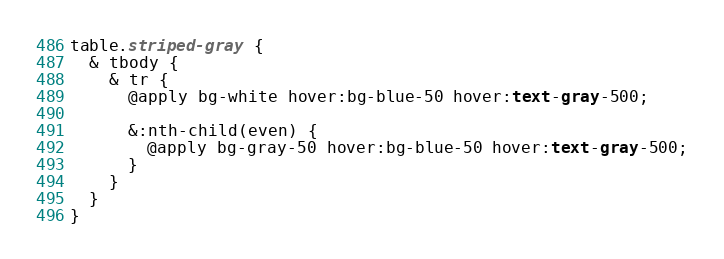Convert code to text. <code><loc_0><loc_0><loc_500><loc_500><_CSS_>table.striped-gray {
  & tbody {
    & tr {
      @apply bg-white hover:bg-blue-50 hover:text-gray-500;

      &:nth-child(even) {
        @apply bg-gray-50 hover:bg-blue-50 hover:text-gray-500;
      }
    }
  }
}
</code> 